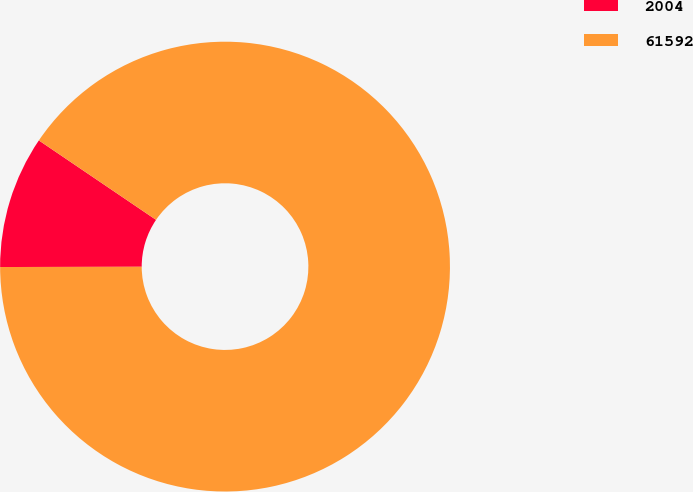Convert chart to OTSL. <chart><loc_0><loc_0><loc_500><loc_500><pie_chart><fcel>2004<fcel>61592<nl><fcel>9.51%<fcel>90.49%<nl></chart> 